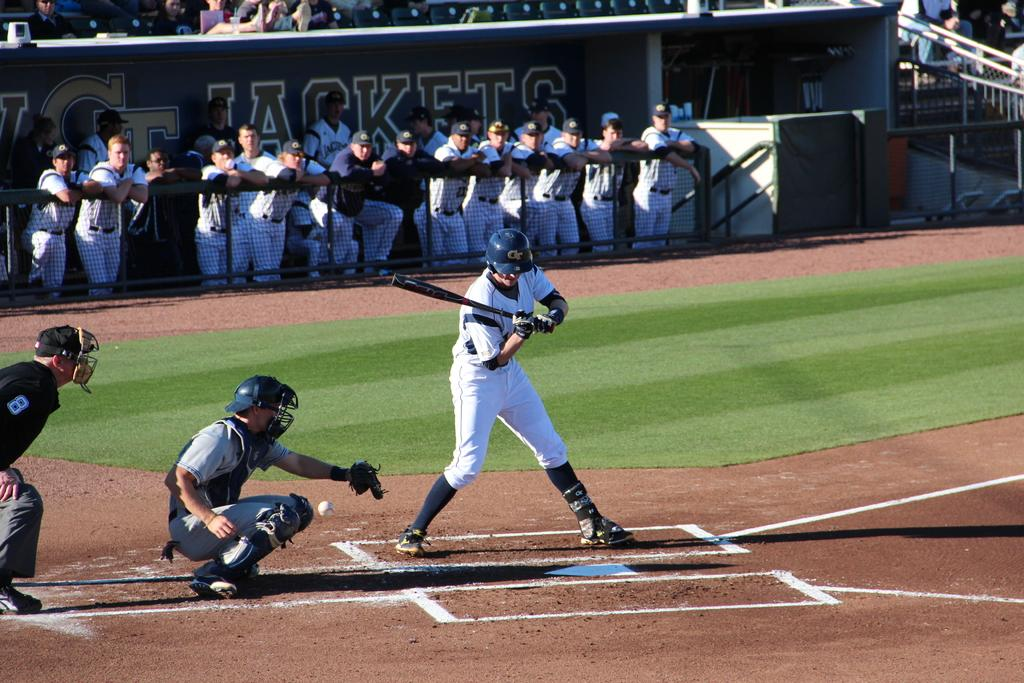Provide a one-sentence caption for the provided image. The batter from the GT Jackets doesn't offer at the pitch low and inside. 